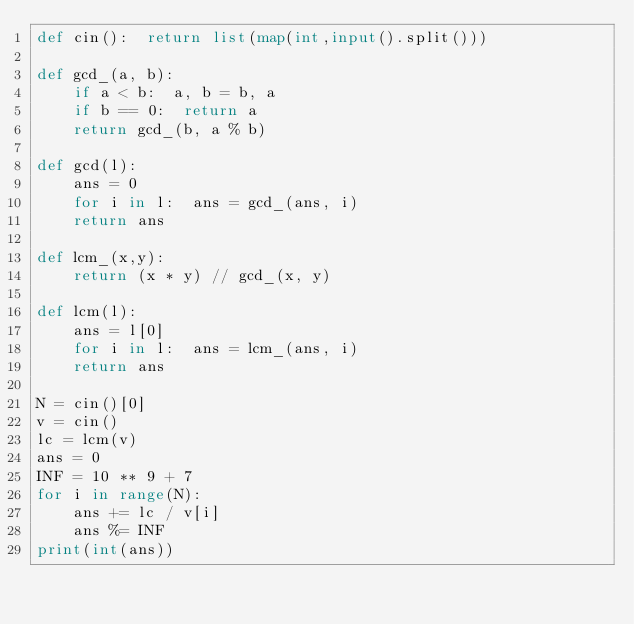Convert code to text. <code><loc_0><loc_0><loc_500><loc_500><_Python_>def cin():  return list(map(int,input().split()))

def gcd_(a, b):
    if a < b:  a, b = b, a
    if b == 0:  return a
    return gcd_(b, a % b)

def gcd(l):
    ans = 0
    for i in l:  ans = gcd_(ans, i)
    return ans

def lcm_(x,y):
    return (x * y) // gcd_(x, y)

def lcm(l):
    ans = l[0]
    for i in l:  ans = lcm_(ans, i)
    return ans

N = cin()[0]
v = cin()
lc = lcm(v)
ans = 0
INF = 10 ** 9 + 7
for i in range(N):
    ans += lc / v[i]
    ans %= INF
print(int(ans))</code> 